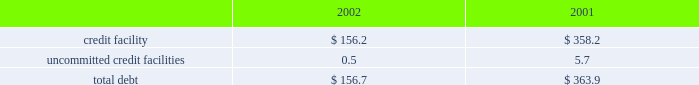Z i m m e r h o l d i n g s , i n c .
A n d s u b s i d i a r i e s 2 0 0 2 f o r m 1 0 - k notes to consolidated financial statements ( continued ) rating as of december 31 , 2002 met such requirement .
Fair value commitments under the credit facility are subject to certain the carrying value of the company 2019s borrowings approxi- fees , including a facility and a utilization fee .
Mates fair value due to their short-term maturities and uncommitted credit facilities variable interest rates .
The company has a $ 26 million uncommitted unsecured 8 .
Derivative financial instruments revolving line of credit .
The purpose of this credit line is to support the working capital needs , letters of credit and the company is exposed to market risk due to changes overdraft needs for the company .
The uncommitted credit in currency exchange rates .
As a result , the company utilizes agreement contains customary affirmative and negative cove- foreign exchange forward contracts to offset the effect of nants and events of default , none of which are considered exchange rate fluctuations on anticipated foreign currency restrictive to the operation of the business .
In addition , this transactions , primarily intercompany sales and purchases uncommitted credit agreement provides for unconditional expected to occur within the next twelve to twenty-four and irrevocable guarantees by the company .
In the event the months .
The company does not hold financial instruments company 2019s long-term debt ratings by both standard and for trading or speculative purposes .
For derivatives which poor 2019s ratings services and moody 2019s investor 2019s service , inc. , qualify as hedges of future cash flows , the effective portion fall below bb- and ba3 , then the company may be required of changes in fair value is temporarily recorded in other to repay all outstanding and contingent obligations .
The comprehensive income , then recognized in earnings when company 2019s credit rating as of december 31 , 2002 met such the hedged item affects earnings .
The ineffective portion of requirement .
This uncommitted credit line matures on a derivative 2019s change in fair value , if any , is reported in july 31 , 2003 .
Outstanding borrowings under this uncommit- earnings .
The net amount recognized in earnings during the ted line of credit as of december 31 , 2002 were $ 0.5 million years ended december 31 , 2002 and 2001 , due to ineffective- with a weighted average interest rate of 6.35 percent .
Ness and amounts excluded from the assessment of hedge the company also has a $ 15 million uncommitted effectiveness , was not significant .
Revolving unsecured line of credit .
The purpose of this line of the notional amounts of outstanding foreign exchange credit is to support short-term working capital needs of the forward contracts , principally japanese yen and the euro , company .
The agreement for this uncommitted unsecured entered into with third parties , at december 31 , 2002 , was line of credit contains customary covenants , none of which $ 252 million .
The fair value of derivative instruments recorded are considered restrictive to the operation of the business .
In accrued liabilities at december 31 , 2002 , was $ 13.8 million , this uncommitted line matures on july 31 , 2003 .
There were or $ 8.5 million net of taxes , which is deferred in other no borrowings under this uncommitted line of credit as of comprehensive income and is expected to be reclassified to december 31 , 2002 .
Earnings over the next two years , of which , $ 7.7 million , or the company has a $ 20 million uncommitted revolving $ 4.8 million , net of taxes , is expected to be reclassified to unsecured line of credit .
The purpose of this line of credit is earnings over the next twelve months .
To support short-term working capital needs of the company .
The pricing is based upon money market rates .
The agree- 9 .
Capital stock and earnings per share ment for this uncommitted unsecured line of credit contains as discussed in note 14 , all of the shares of company customary covenants , none of which are considered restrictive common stock were distributed at the distribution by the to the operation of the business .
This uncommitted line former parent to its stockholders in the form of a dividend matures on july 31 , 2003 .
There were no borrowings under of one share of company common stock , and the associated this uncommitted line of credit as of december 31 , 2002 .
Preferred stock purchase right , for every ten shares of the company was in compliance with all covenants common stock of the former parent .
In july 2001 the board under all three of the uncommitted credit facilities as of of directors of the company adopted a rights agreement december 31 , 2002 .
The company had no long-term debt intended to have anti-takeover effects .
Under this agreement as of december 31 , 2002 .
One right attaches to each share of company common stock .
Outstanding debt as of december 31 , 2002 and 2001 , the rights will not become exercisable until the earlier of : consist of the following ( in millions ) : a ) the company learns that a person or group acquired , or 2002 2001 obtained the right to acquire , beneficial ownership of securi- credit facility $ 156.2 $ 358.2 ties representing more than 20 percent of the shares of uncommitted credit facilities 0.5 5.7 company common stock then outstanding , or b ) such date , if any , as may be designated by the board of directorstotal debt $ 156.7 $ 363.9 following the commencement of , or first public disclosure of the company paid $ 13.0 million and $ 4.6 million in an intention to commence , a tender offer or exchange offer interest charges during 2002 and 2001 , respectively. .
Z i m m e r h o l d i n g s , i n c .
A n d s u b s i d i a r i e s 2 0 0 2 f o r m 1 0 - k notes to consolidated financial statements ( continued ) rating as of december 31 , 2002 met such requirement .
Fair value commitments under the credit facility are subject to certain the carrying value of the company 2019s borrowings approxi- fees , including a facility and a utilization fee .
Mates fair value due to their short-term maturities and uncommitted credit facilities variable interest rates .
The company has a $ 26 million uncommitted unsecured 8 .
Derivative financial instruments revolving line of credit .
The purpose of this credit line is to support the working capital needs , letters of credit and the company is exposed to market risk due to changes overdraft needs for the company .
The uncommitted credit in currency exchange rates .
As a result , the company utilizes agreement contains customary affirmative and negative cove- foreign exchange forward contracts to offset the effect of nants and events of default , none of which are considered exchange rate fluctuations on anticipated foreign currency restrictive to the operation of the business .
In addition , this transactions , primarily intercompany sales and purchases uncommitted credit agreement provides for unconditional expected to occur within the next twelve to twenty-four and irrevocable guarantees by the company .
In the event the months .
The company does not hold financial instruments company 2019s long-term debt ratings by both standard and for trading or speculative purposes .
For derivatives which poor 2019s ratings services and moody 2019s investor 2019s service , inc. , qualify as hedges of future cash flows , the effective portion fall below bb- and ba3 , then the company may be required of changes in fair value is temporarily recorded in other to repay all outstanding and contingent obligations .
The comprehensive income , then recognized in earnings when company 2019s credit rating as of december 31 , 2002 met such the hedged item affects earnings .
The ineffective portion of requirement .
This uncommitted credit line matures on a derivative 2019s change in fair value , if any , is reported in july 31 , 2003 .
Outstanding borrowings under this uncommit- earnings .
The net amount recognized in earnings during the ted line of credit as of december 31 , 2002 were $ 0.5 million years ended december 31 , 2002 and 2001 , due to ineffective- with a weighted average interest rate of 6.35 percent .
Ness and amounts excluded from the assessment of hedge the company also has a $ 15 million uncommitted effectiveness , was not significant .
Revolving unsecured line of credit .
The purpose of this line of the notional amounts of outstanding foreign exchange credit is to support short-term working capital needs of the forward contracts , principally japanese yen and the euro , company .
The agreement for this uncommitted unsecured entered into with third parties , at december 31 , 2002 , was line of credit contains customary covenants , none of which $ 252 million .
The fair value of derivative instruments recorded are considered restrictive to the operation of the business .
In accrued liabilities at december 31 , 2002 , was $ 13.8 million , this uncommitted line matures on july 31 , 2003 .
There were or $ 8.5 million net of taxes , which is deferred in other no borrowings under this uncommitted line of credit as of comprehensive income and is expected to be reclassified to december 31 , 2002 .
Earnings over the next two years , of which , $ 7.7 million , or the company has a $ 20 million uncommitted revolving $ 4.8 million , net of taxes , is expected to be reclassified to unsecured line of credit .
The purpose of this line of credit is earnings over the next twelve months .
To support short-term working capital needs of the company .
The pricing is based upon money market rates .
The agree- 9 .
Capital stock and earnings per share ment for this uncommitted unsecured line of credit contains as discussed in note 14 , all of the shares of company customary covenants , none of which are considered restrictive common stock were distributed at the distribution by the to the operation of the business .
This uncommitted line former parent to its stockholders in the form of a dividend matures on july 31 , 2003 .
There were no borrowings under of one share of company common stock , and the associated this uncommitted line of credit as of december 31 , 2002 .
Preferred stock purchase right , for every ten shares of the company was in compliance with all covenants common stock of the former parent .
In july 2001 the board under all three of the uncommitted credit facilities as of of directors of the company adopted a rights agreement december 31 , 2002 .
The company had no long-term debt intended to have anti-takeover effects .
Under this agreement as of december 31 , 2002 .
One right attaches to each share of company common stock .
Outstanding debt as of december 31 , 2002 and 2001 , the rights will not become exercisable until the earlier of : consist of the following ( in millions ) : a ) the company learns that a person or group acquired , or 2002 2001 obtained the right to acquire , beneficial ownership of securi- credit facility $ 156.2 $ 358.2 ties representing more than 20 percent of the shares of uncommitted credit facilities 0.5 5.7 company common stock then outstanding , or b ) such date , if any , as may be designated by the board of directorstotal debt $ 156.7 $ 363.9 following the commencement of , or first public disclosure of the company paid $ 13.0 million and $ 4.6 million in an intention to commence , a tender offer or exchange offer interest charges during 2002 and 2001 , respectively. .
What was the percentage change of total debt from 2001 to 2002? 
Computations: ((156.7 - 363.9) / 363.9)
Answer: -0.56939. 